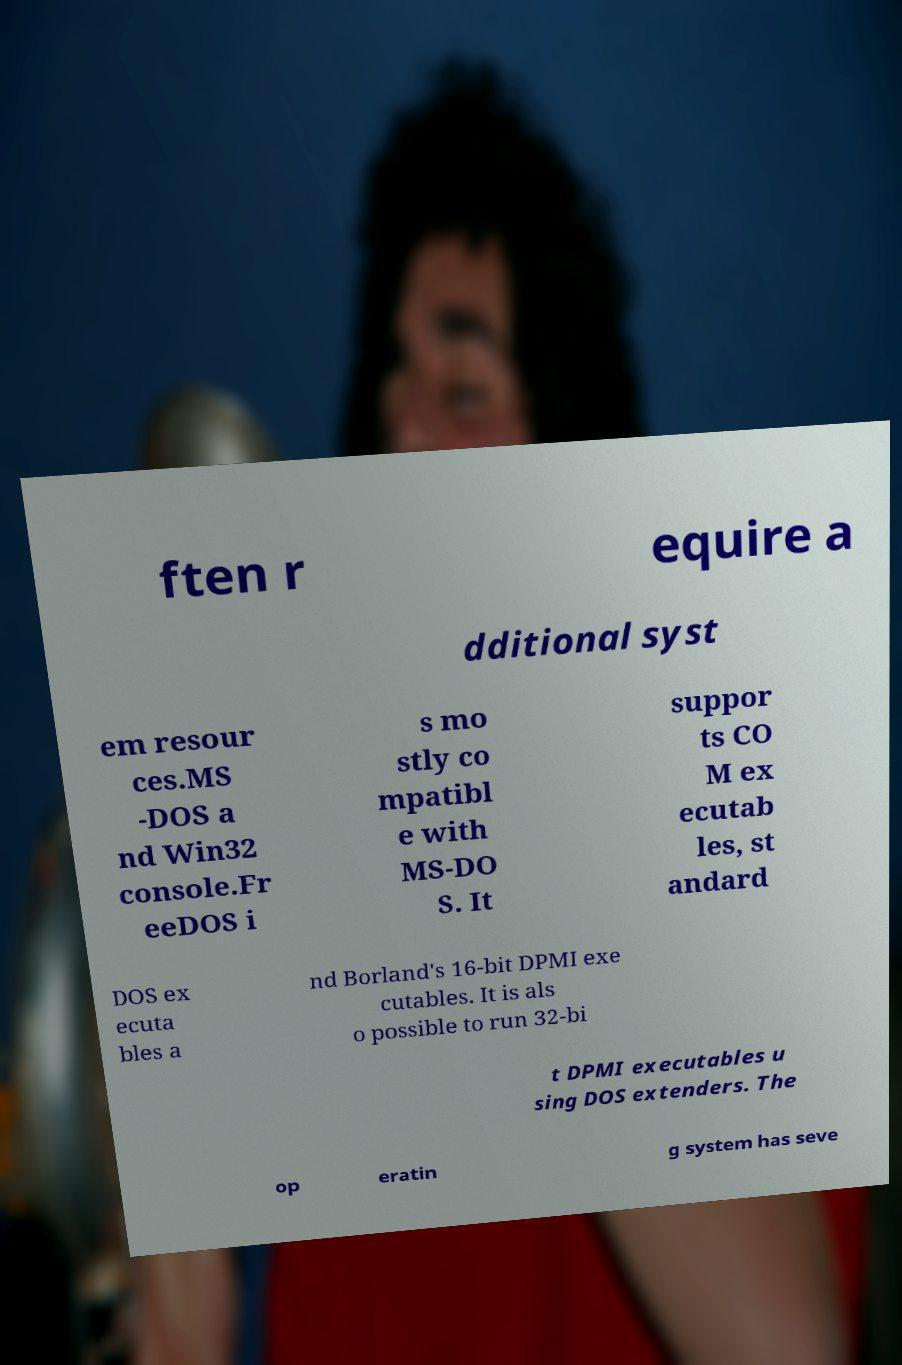Could you assist in decoding the text presented in this image and type it out clearly? ften r equire a dditional syst em resour ces.MS -DOS a nd Win32 console.Fr eeDOS i s mo stly co mpatibl e with MS-DO S. It suppor ts CO M ex ecutab les, st andard DOS ex ecuta bles a nd Borland's 16-bit DPMI exe cutables. It is als o possible to run 32-bi t DPMI executables u sing DOS extenders. The op eratin g system has seve 